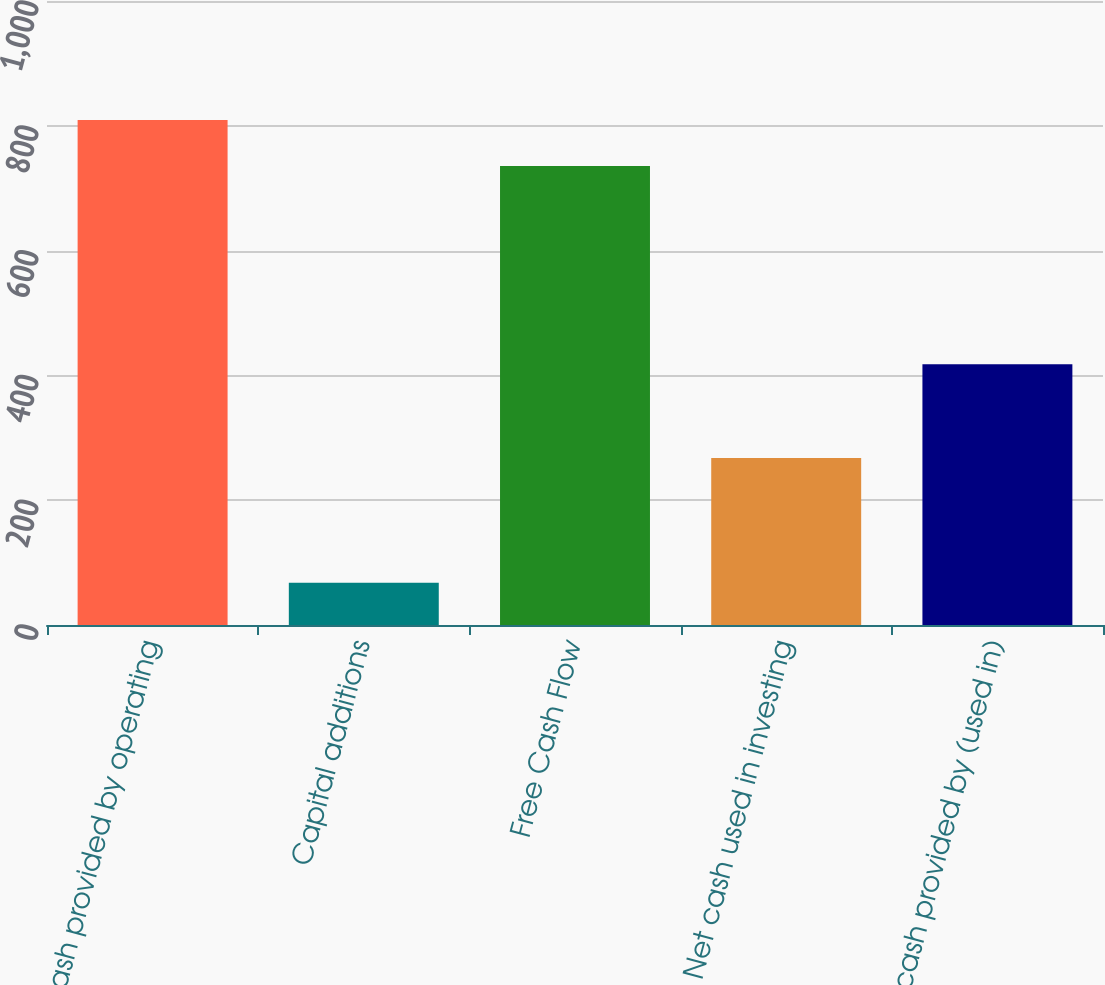<chart> <loc_0><loc_0><loc_500><loc_500><bar_chart><fcel>Net cash provided by operating<fcel>Capital additions<fcel>Free Cash Flow<fcel>Net cash used in investing<fcel>Net cash provided by (used in)<nl><fcel>809.16<fcel>67.7<fcel>735.6<fcel>267.6<fcel>417.7<nl></chart> 